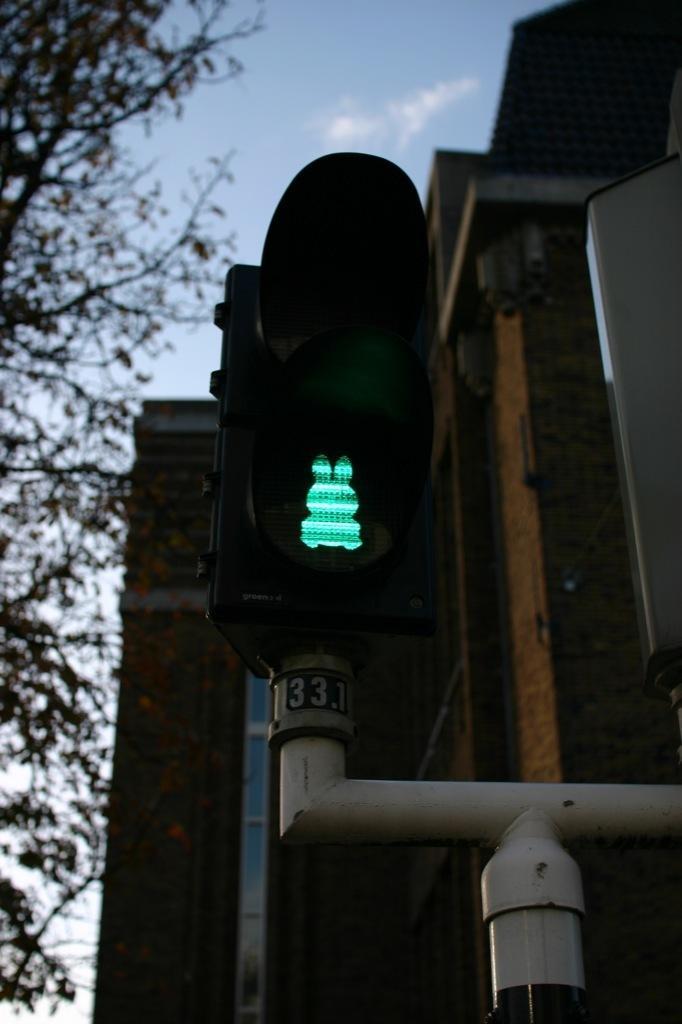In one or two sentences, can you explain what this image depicts? In this picture there is a traffic signal which has a green light on it is attached to a pole below it and there is a building behind it and there is a tree in the left corner. 